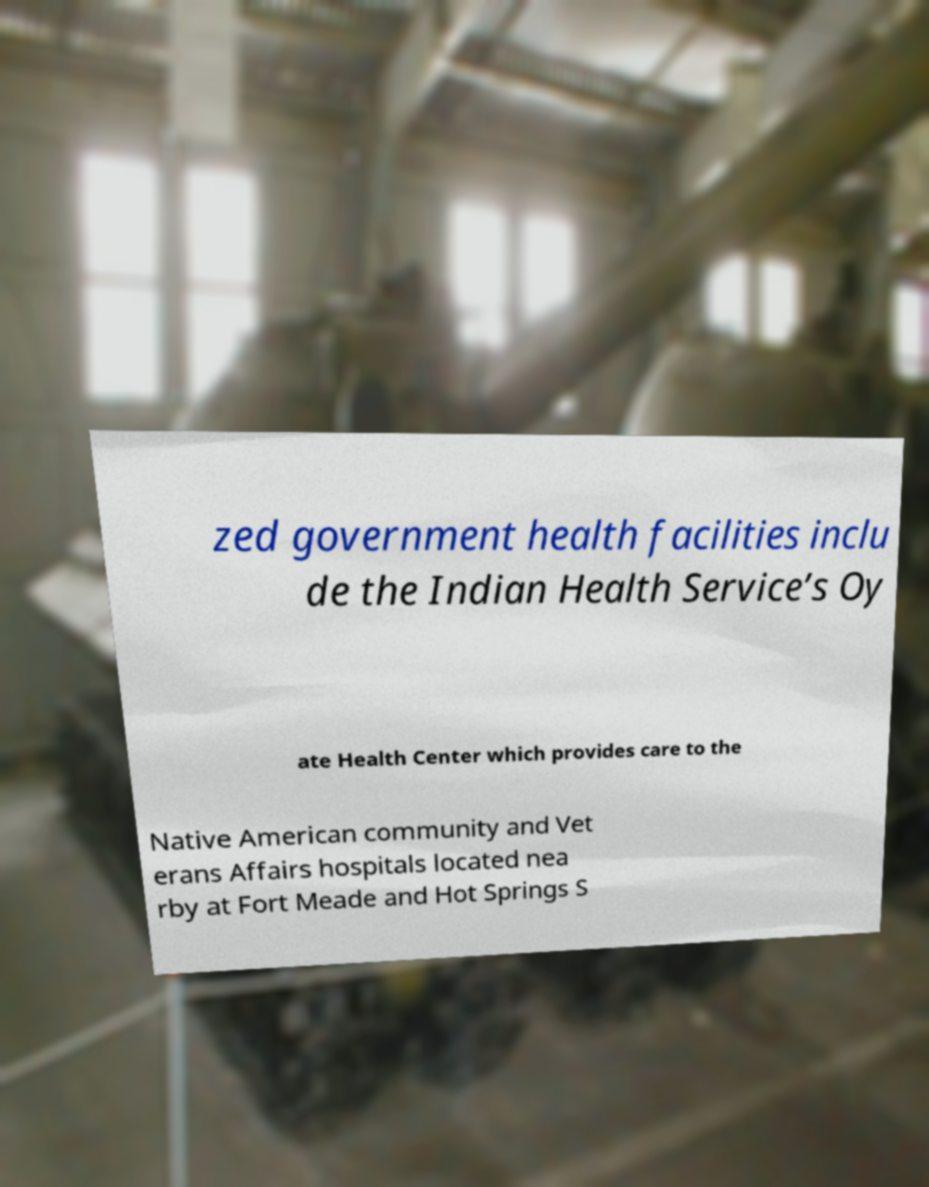Can you accurately transcribe the text from the provided image for me? zed government health facilities inclu de the Indian Health Service’s Oy ate Health Center which provides care to the Native American community and Vet erans Affairs hospitals located nea rby at Fort Meade and Hot Springs S 